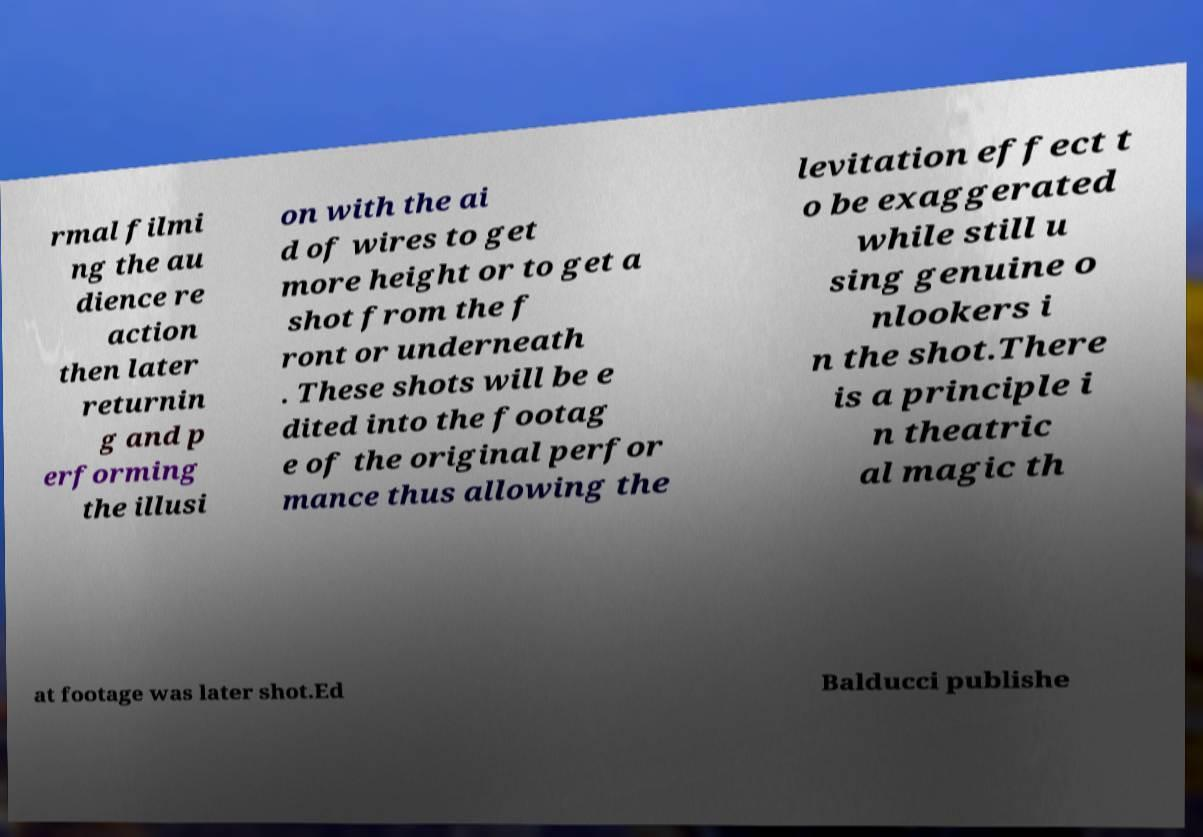What messages or text are displayed in this image? I need them in a readable, typed format. rmal filmi ng the au dience re action then later returnin g and p erforming the illusi on with the ai d of wires to get more height or to get a shot from the f ront or underneath . These shots will be e dited into the footag e of the original perfor mance thus allowing the levitation effect t o be exaggerated while still u sing genuine o nlookers i n the shot.There is a principle i n theatric al magic th at footage was later shot.Ed Balducci publishe 